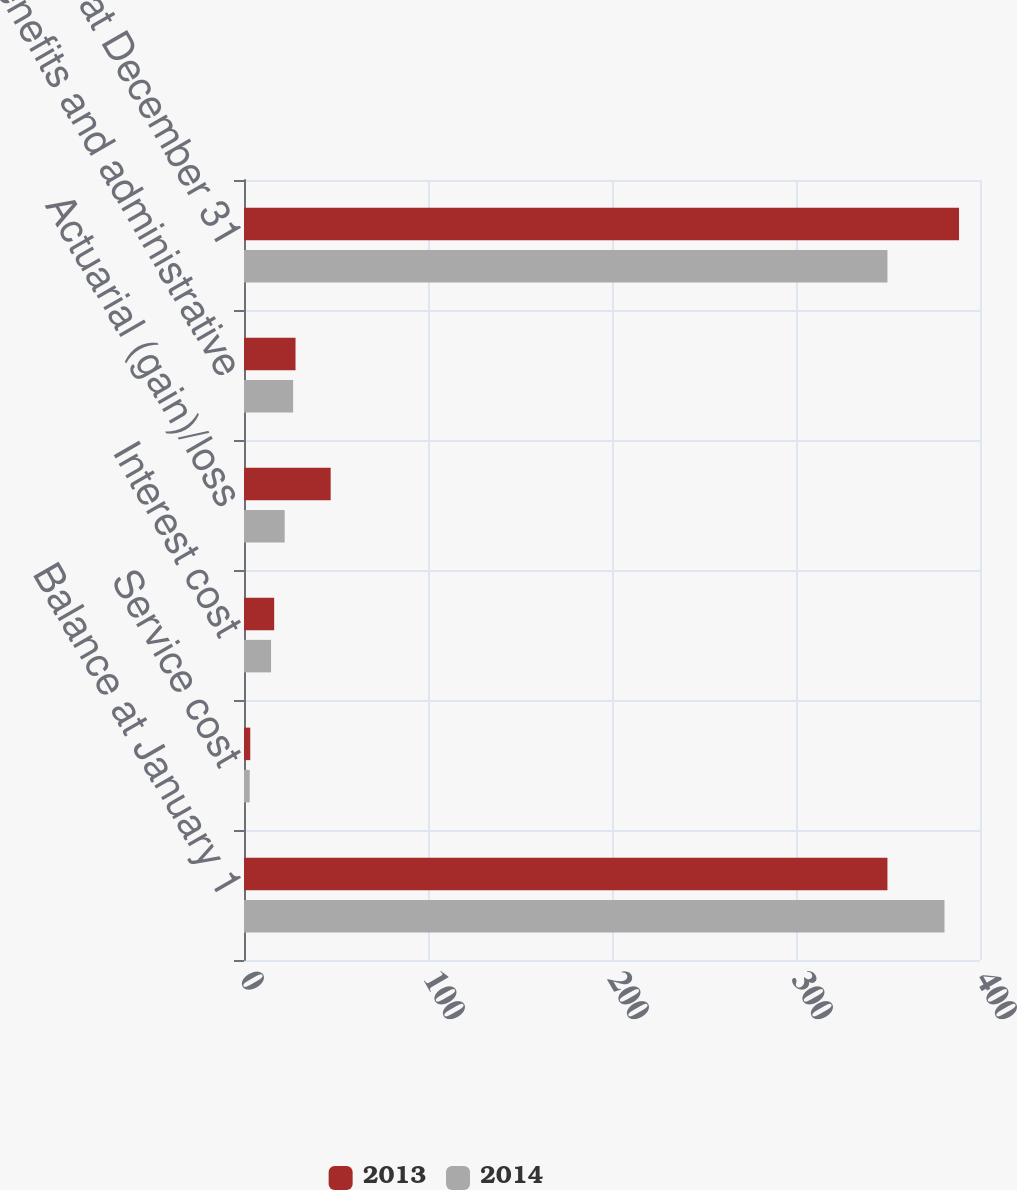Convert chart. <chart><loc_0><loc_0><loc_500><loc_500><stacked_bar_chart><ecel><fcel>Balance at January 1<fcel>Service cost<fcel>Interest cost<fcel>Actuarial (gain)/loss<fcel>Benefits and administrative<fcel>Balance at December 31<nl><fcel>2013<fcel>349.7<fcel>3.4<fcel>16.4<fcel>47.1<fcel>28<fcel>388.6<nl><fcel>2014<fcel>380.7<fcel>3.1<fcel>14.7<fcel>22.1<fcel>26.7<fcel>349.7<nl></chart> 